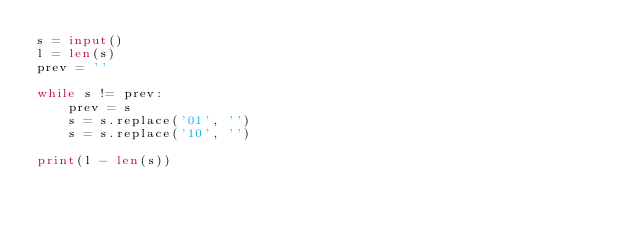<code> <loc_0><loc_0><loc_500><loc_500><_Python_>s = input()
l = len(s)
prev = ''

while s != prev:
    prev = s
    s = s.replace('01', '')
    s = s.replace('10', '')

print(l - len(s))</code> 